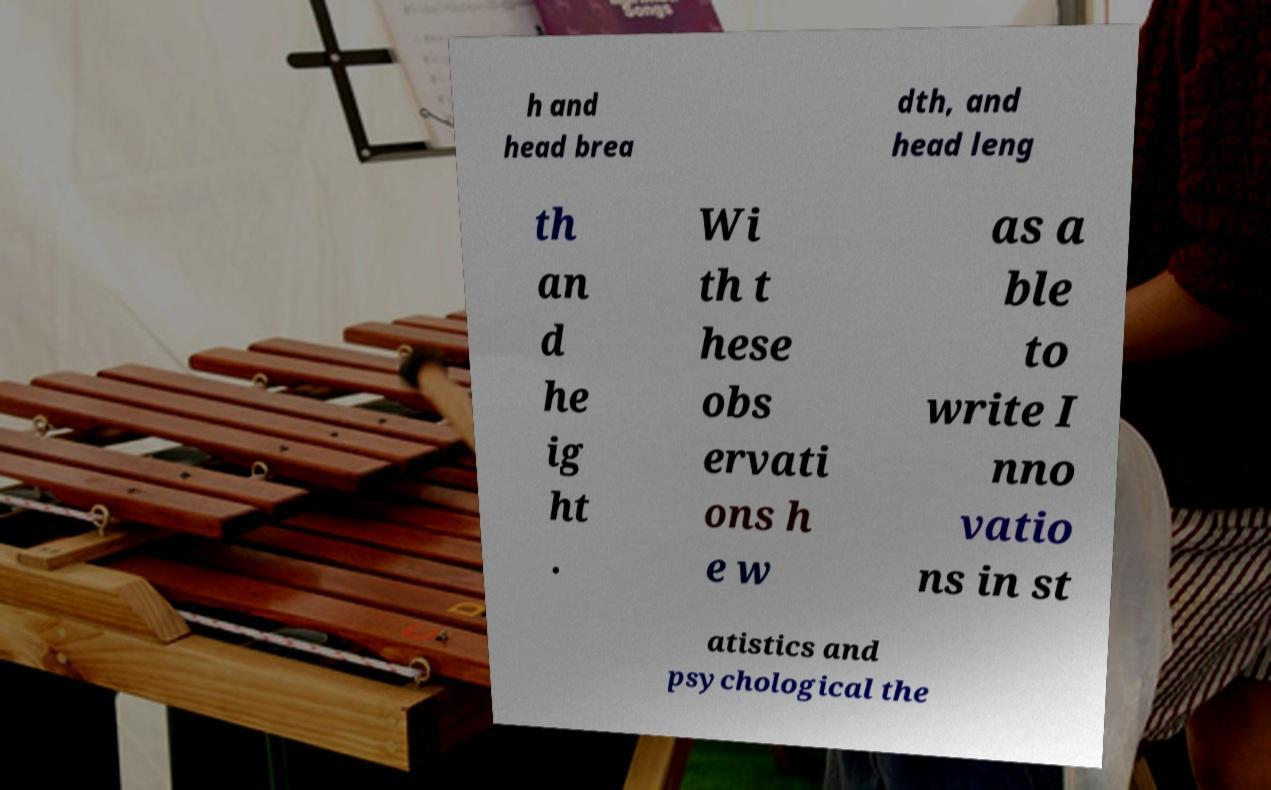Please read and relay the text visible in this image. What does it say? h and head brea dth, and head leng th an d he ig ht . Wi th t hese obs ervati ons h e w as a ble to write I nno vatio ns in st atistics and psychological the 